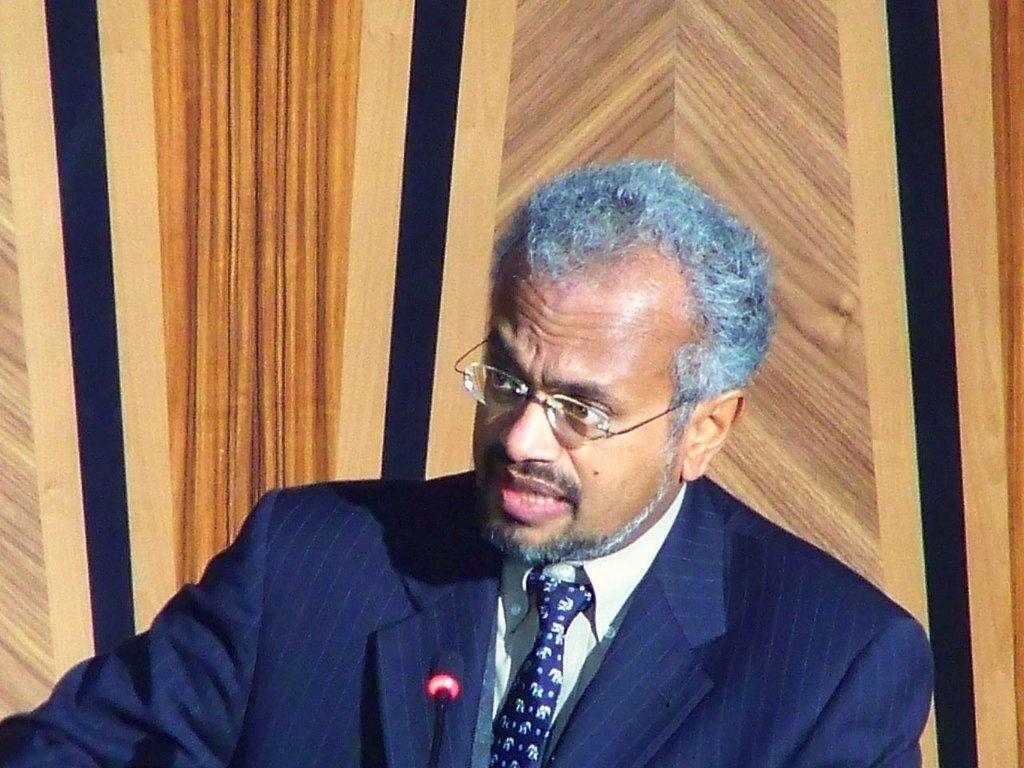What is the man in the image doing? The man is talking on a microphone. What is the man wearing in the image? The man is wearing a suit. Can you describe any accessories the man is wearing in the image? The man has spectacles. What type of knife is the man using to cut the meat in the image? There is no knife or meat present in the image; the man is talking on a microphone. 